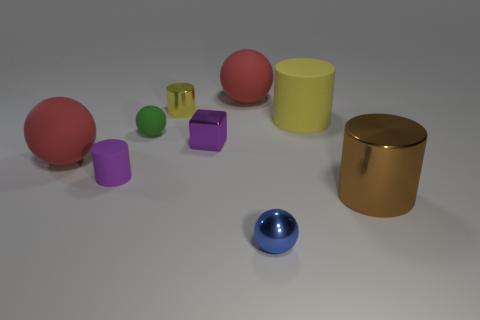Add 1 large brown things. How many objects exist? 10 Subtract all blocks. How many objects are left? 8 Subtract 0 cyan spheres. How many objects are left? 9 Subtract all red matte things. Subtract all green things. How many objects are left? 6 Add 7 large matte balls. How many large matte balls are left? 9 Add 5 tiny red metal cylinders. How many tiny red metal cylinders exist? 5 